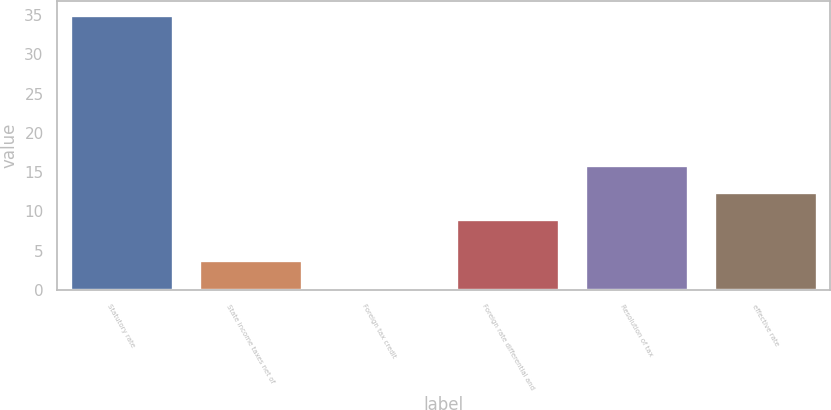Convert chart to OTSL. <chart><loc_0><loc_0><loc_500><loc_500><bar_chart><fcel>Statutory rate<fcel>State income taxes net of<fcel>Foreign tax credit<fcel>Foreign rate differential and<fcel>Resolution of tax<fcel>effective rate<nl><fcel>35<fcel>3.77<fcel>0.3<fcel>9<fcel>15.94<fcel>12.47<nl></chart> 